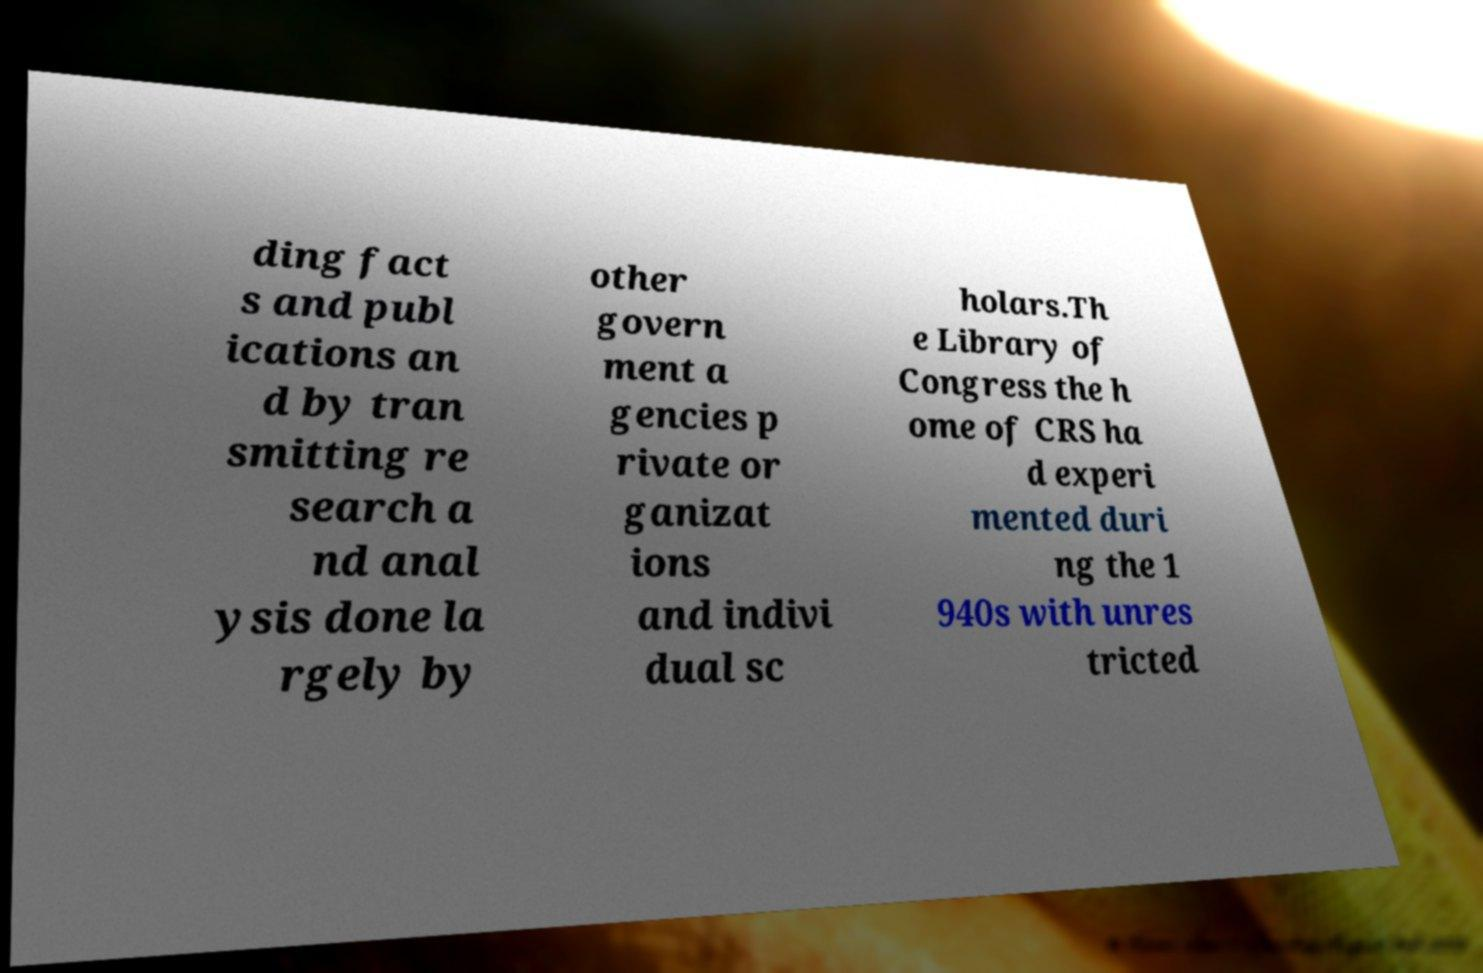Can you read and provide the text displayed in the image?This photo seems to have some interesting text. Can you extract and type it out for me? ding fact s and publ ications an d by tran smitting re search a nd anal ysis done la rgely by other govern ment a gencies p rivate or ganizat ions and indivi dual sc holars.Th e Library of Congress the h ome of CRS ha d experi mented duri ng the 1 940s with unres tricted 